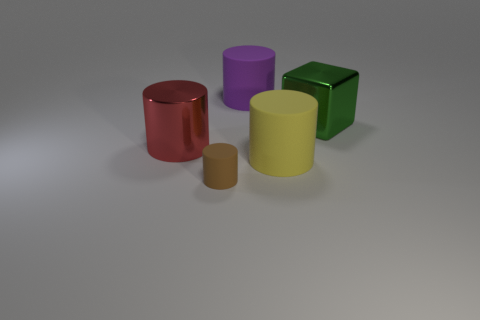Are there more red shiny cylinders that are behind the purple cylinder than large red spheres?
Your answer should be compact. No. Are there any yellow rubber cylinders to the left of the yellow matte cylinder?
Give a very brief answer. No. Does the purple thing have the same size as the green metallic cube?
Your answer should be compact. Yes. The brown thing that is the same shape as the yellow object is what size?
Provide a succinct answer. Small. Is there any other thing that has the same size as the brown thing?
Make the answer very short. No. There is a large object in front of the metal object that is left of the green metal object; what is its material?
Provide a short and direct response. Rubber. Does the large green metal object have the same shape as the purple thing?
Your answer should be compact. No. How many large objects are both in front of the large red cylinder and on the left side of the brown cylinder?
Provide a succinct answer. 0. Are there the same number of large green blocks that are in front of the brown thing and yellow rubber objects that are to the left of the yellow object?
Provide a succinct answer. Yes. Is the size of the green shiny thing right of the large red object the same as the rubber cylinder that is on the left side of the big purple matte thing?
Your answer should be very brief. No. 